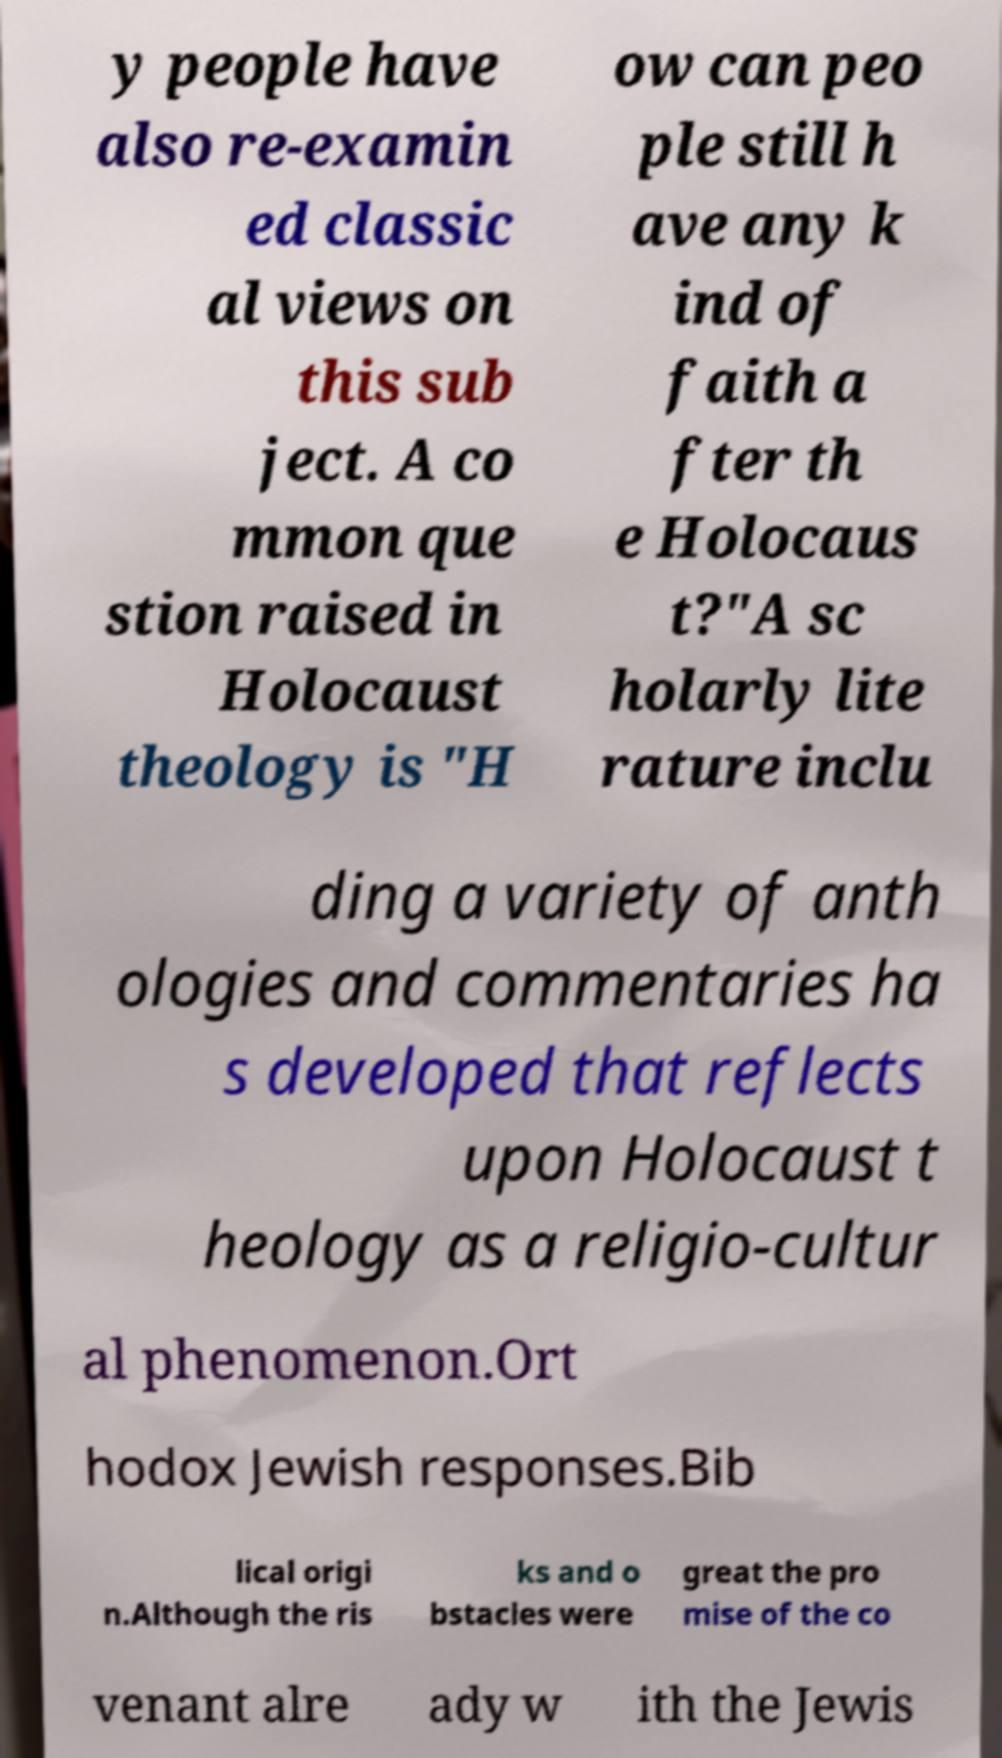For documentation purposes, I need the text within this image transcribed. Could you provide that? y people have also re-examin ed classic al views on this sub ject. A co mmon que stion raised in Holocaust theology is "H ow can peo ple still h ave any k ind of faith a fter th e Holocaus t?"A sc holarly lite rature inclu ding a variety of anth ologies and commentaries ha s developed that reflects upon Holocaust t heology as a religio-cultur al phenomenon.Ort hodox Jewish responses.Bib lical origi n.Although the ris ks and o bstacles were great the pro mise of the co venant alre ady w ith the Jewis 